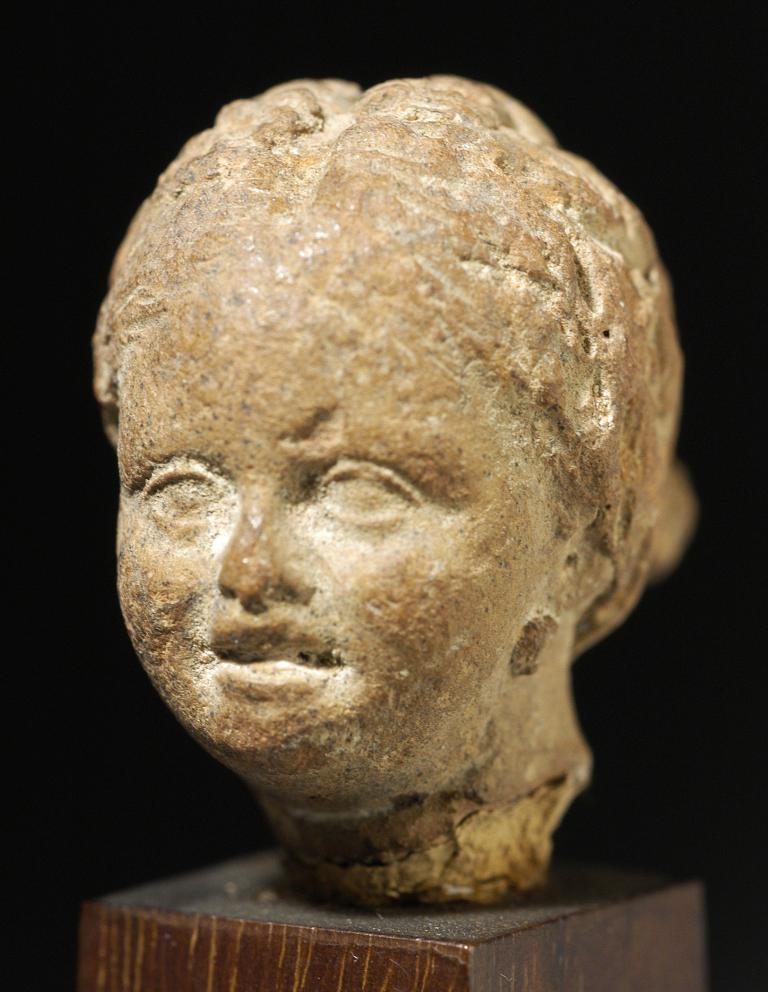In one or two sentences, can you explain what this image depicts? In this image we can see a sculpture on a platform. In the background the image is blur. 